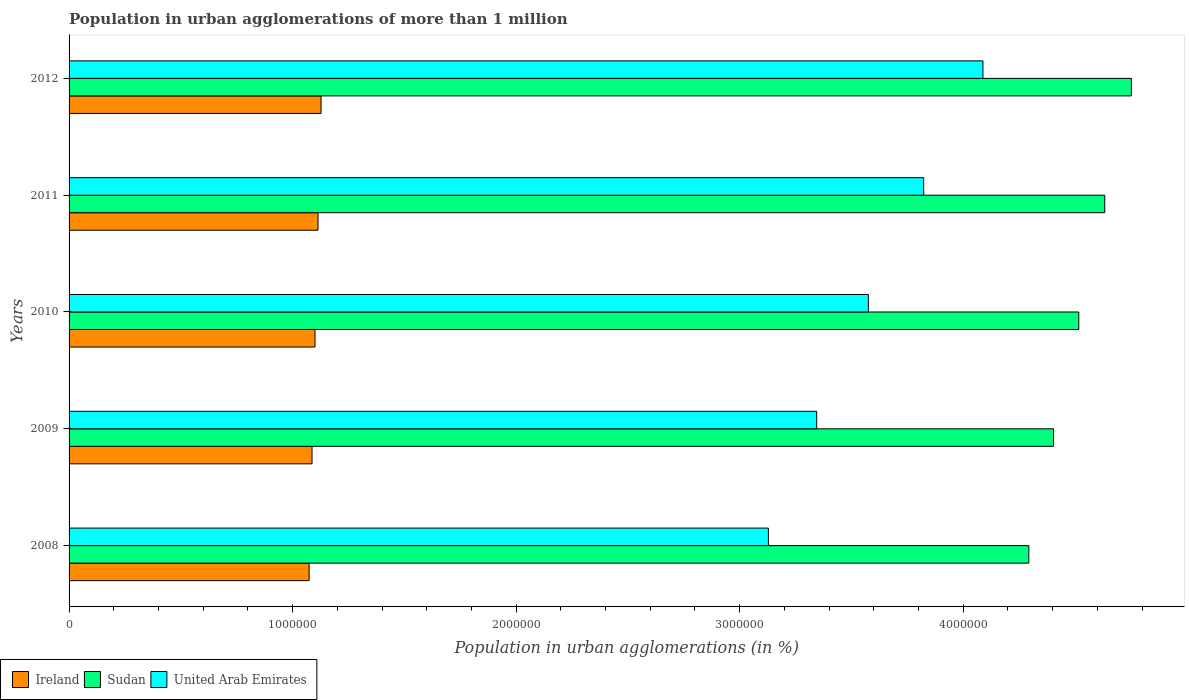How many different coloured bars are there?
Your response must be concise. 3. How many groups of bars are there?
Ensure brevity in your answer.  5. Are the number of bars per tick equal to the number of legend labels?
Give a very brief answer. Yes. Are the number of bars on each tick of the Y-axis equal?
Make the answer very short. Yes. How many bars are there on the 4th tick from the bottom?
Your answer should be very brief. 3. What is the label of the 3rd group of bars from the top?
Your answer should be very brief. 2010. In how many cases, is the number of bars for a given year not equal to the number of legend labels?
Ensure brevity in your answer.  0. What is the population in urban agglomerations in Ireland in 2012?
Your answer should be compact. 1.13e+06. Across all years, what is the maximum population in urban agglomerations in United Arab Emirates?
Offer a very short reply. 4.09e+06. Across all years, what is the minimum population in urban agglomerations in Sudan?
Give a very brief answer. 4.29e+06. In which year was the population in urban agglomerations in Ireland maximum?
Your answer should be very brief. 2012. What is the total population in urban agglomerations in United Arab Emirates in the graph?
Offer a very short reply. 1.80e+07. What is the difference between the population in urban agglomerations in Ireland in 2011 and that in 2012?
Provide a succinct answer. -1.36e+04. What is the difference between the population in urban agglomerations in Ireland in 2010 and the population in urban agglomerations in United Arab Emirates in 2008?
Keep it short and to the point. -2.03e+06. What is the average population in urban agglomerations in Ireland per year?
Give a very brief answer. 1.10e+06. In the year 2009, what is the difference between the population in urban agglomerations in Ireland and population in urban agglomerations in Sudan?
Provide a succinct answer. -3.32e+06. In how many years, is the population in urban agglomerations in Ireland greater than 600000 %?
Offer a very short reply. 5. What is the ratio of the population in urban agglomerations in United Arab Emirates in 2008 to that in 2009?
Offer a very short reply. 0.94. Is the difference between the population in urban agglomerations in Ireland in 2009 and 2010 greater than the difference between the population in urban agglomerations in Sudan in 2009 and 2010?
Keep it short and to the point. Yes. What is the difference between the highest and the second highest population in urban agglomerations in United Arab Emirates?
Your answer should be very brief. 2.65e+05. What is the difference between the highest and the lowest population in urban agglomerations in United Arab Emirates?
Offer a very short reply. 9.60e+05. In how many years, is the population in urban agglomerations in Sudan greater than the average population in urban agglomerations in Sudan taken over all years?
Keep it short and to the point. 2. What does the 3rd bar from the top in 2009 represents?
Your response must be concise. Ireland. What does the 3rd bar from the bottom in 2009 represents?
Give a very brief answer. United Arab Emirates. Is it the case that in every year, the sum of the population in urban agglomerations in Ireland and population in urban agglomerations in United Arab Emirates is greater than the population in urban agglomerations in Sudan?
Your answer should be very brief. No. Are all the bars in the graph horizontal?
Your answer should be compact. Yes. How many years are there in the graph?
Offer a very short reply. 5. Does the graph contain grids?
Your answer should be compact. No. Where does the legend appear in the graph?
Give a very brief answer. Bottom left. How many legend labels are there?
Your answer should be compact. 3. What is the title of the graph?
Give a very brief answer. Population in urban agglomerations of more than 1 million. Does "Kosovo" appear as one of the legend labels in the graph?
Your answer should be very brief. No. What is the label or title of the X-axis?
Your response must be concise. Population in urban agglomerations (in %). What is the Population in urban agglomerations (in %) of Ireland in 2008?
Offer a terse response. 1.07e+06. What is the Population in urban agglomerations (in %) in Sudan in 2008?
Your response must be concise. 4.29e+06. What is the Population in urban agglomerations (in %) in United Arab Emirates in 2008?
Your answer should be very brief. 3.13e+06. What is the Population in urban agglomerations (in %) in Ireland in 2009?
Your answer should be very brief. 1.09e+06. What is the Population in urban agglomerations (in %) of Sudan in 2009?
Make the answer very short. 4.40e+06. What is the Population in urban agglomerations (in %) in United Arab Emirates in 2009?
Your answer should be compact. 3.34e+06. What is the Population in urban agglomerations (in %) of Ireland in 2010?
Ensure brevity in your answer.  1.10e+06. What is the Population in urban agglomerations (in %) of Sudan in 2010?
Give a very brief answer. 4.52e+06. What is the Population in urban agglomerations (in %) of United Arab Emirates in 2010?
Your answer should be compact. 3.58e+06. What is the Population in urban agglomerations (in %) of Ireland in 2011?
Give a very brief answer. 1.11e+06. What is the Population in urban agglomerations (in %) of Sudan in 2011?
Ensure brevity in your answer.  4.63e+06. What is the Population in urban agglomerations (in %) in United Arab Emirates in 2011?
Provide a succinct answer. 3.82e+06. What is the Population in urban agglomerations (in %) of Ireland in 2012?
Ensure brevity in your answer.  1.13e+06. What is the Population in urban agglomerations (in %) in Sudan in 2012?
Your answer should be compact. 4.75e+06. What is the Population in urban agglomerations (in %) in United Arab Emirates in 2012?
Give a very brief answer. 4.09e+06. Across all years, what is the maximum Population in urban agglomerations (in %) in Ireland?
Provide a short and direct response. 1.13e+06. Across all years, what is the maximum Population in urban agglomerations (in %) in Sudan?
Provide a succinct answer. 4.75e+06. Across all years, what is the maximum Population in urban agglomerations (in %) in United Arab Emirates?
Give a very brief answer. 4.09e+06. Across all years, what is the minimum Population in urban agglomerations (in %) in Ireland?
Your response must be concise. 1.07e+06. Across all years, what is the minimum Population in urban agglomerations (in %) in Sudan?
Make the answer very short. 4.29e+06. Across all years, what is the minimum Population in urban agglomerations (in %) of United Arab Emirates?
Provide a short and direct response. 3.13e+06. What is the total Population in urban agglomerations (in %) in Ireland in the graph?
Offer a terse response. 5.50e+06. What is the total Population in urban agglomerations (in %) of Sudan in the graph?
Your response must be concise. 2.26e+07. What is the total Population in urban agglomerations (in %) in United Arab Emirates in the graph?
Offer a very short reply. 1.80e+07. What is the difference between the Population in urban agglomerations (in %) in Ireland in 2008 and that in 2009?
Make the answer very short. -1.31e+04. What is the difference between the Population in urban agglomerations (in %) of Sudan in 2008 and that in 2009?
Provide a short and direct response. -1.10e+05. What is the difference between the Population in urban agglomerations (in %) in United Arab Emirates in 2008 and that in 2009?
Offer a terse response. -2.16e+05. What is the difference between the Population in urban agglomerations (in %) of Ireland in 2008 and that in 2010?
Make the answer very short. -2.63e+04. What is the difference between the Population in urban agglomerations (in %) of Sudan in 2008 and that in 2010?
Provide a short and direct response. -2.24e+05. What is the difference between the Population in urban agglomerations (in %) of United Arab Emirates in 2008 and that in 2010?
Give a very brief answer. -4.47e+05. What is the difference between the Population in urban agglomerations (in %) in Ireland in 2008 and that in 2011?
Your answer should be very brief. -3.97e+04. What is the difference between the Population in urban agglomerations (in %) of Sudan in 2008 and that in 2011?
Make the answer very short. -3.40e+05. What is the difference between the Population in urban agglomerations (in %) of United Arab Emirates in 2008 and that in 2011?
Keep it short and to the point. -6.95e+05. What is the difference between the Population in urban agglomerations (in %) of Ireland in 2008 and that in 2012?
Your answer should be very brief. -5.33e+04. What is the difference between the Population in urban agglomerations (in %) of Sudan in 2008 and that in 2012?
Offer a terse response. -4.59e+05. What is the difference between the Population in urban agglomerations (in %) of United Arab Emirates in 2008 and that in 2012?
Keep it short and to the point. -9.60e+05. What is the difference between the Population in urban agglomerations (in %) in Ireland in 2009 and that in 2010?
Offer a very short reply. -1.33e+04. What is the difference between the Population in urban agglomerations (in %) in Sudan in 2009 and that in 2010?
Keep it short and to the point. -1.13e+05. What is the difference between the Population in urban agglomerations (in %) in United Arab Emirates in 2009 and that in 2010?
Keep it short and to the point. -2.31e+05. What is the difference between the Population in urban agglomerations (in %) in Ireland in 2009 and that in 2011?
Offer a very short reply. -2.67e+04. What is the difference between the Population in urban agglomerations (in %) of Sudan in 2009 and that in 2011?
Give a very brief answer. -2.29e+05. What is the difference between the Population in urban agglomerations (in %) in United Arab Emirates in 2009 and that in 2011?
Your response must be concise. -4.79e+05. What is the difference between the Population in urban agglomerations (in %) in Ireland in 2009 and that in 2012?
Offer a very short reply. -4.03e+04. What is the difference between the Population in urban agglomerations (in %) of Sudan in 2009 and that in 2012?
Keep it short and to the point. -3.48e+05. What is the difference between the Population in urban agglomerations (in %) of United Arab Emirates in 2009 and that in 2012?
Offer a terse response. -7.44e+05. What is the difference between the Population in urban agglomerations (in %) of Ireland in 2010 and that in 2011?
Ensure brevity in your answer.  -1.34e+04. What is the difference between the Population in urban agglomerations (in %) in Sudan in 2010 and that in 2011?
Provide a short and direct response. -1.16e+05. What is the difference between the Population in urban agglomerations (in %) in United Arab Emirates in 2010 and that in 2011?
Give a very brief answer. -2.47e+05. What is the difference between the Population in urban agglomerations (in %) in Ireland in 2010 and that in 2012?
Keep it short and to the point. -2.70e+04. What is the difference between the Population in urban agglomerations (in %) of Sudan in 2010 and that in 2012?
Ensure brevity in your answer.  -2.35e+05. What is the difference between the Population in urban agglomerations (in %) in United Arab Emirates in 2010 and that in 2012?
Your answer should be compact. -5.12e+05. What is the difference between the Population in urban agglomerations (in %) of Ireland in 2011 and that in 2012?
Provide a succinct answer. -1.36e+04. What is the difference between the Population in urban agglomerations (in %) of Sudan in 2011 and that in 2012?
Provide a short and direct response. -1.19e+05. What is the difference between the Population in urban agglomerations (in %) of United Arab Emirates in 2011 and that in 2012?
Give a very brief answer. -2.65e+05. What is the difference between the Population in urban agglomerations (in %) of Ireland in 2008 and the Population in urban agglomerations (in %) of Sudan in 2009?
Make the answer very short. -3.33e+06. What is the difference between the Population in urban agglomerations (in %) of Ireland in 2008 and the Population in urban agglomerations (in %) of United Arab Emirates in 2009?
Make the answer very short. -2.27e+06. What is the difference between the Population in urban agglomerations (in %) in Sudan in 2008 and the Population in urban agglomerations (in %) in United Arab Emirates in 2009?
Offer a terse response. 9.49e+05. What is the difference between the Population in urban agglomerations (in %) in Ireland in 2008 and the Population in urban agglomerations (in %) in Sudan in 2010?
Offer a terse response. -3.44e+06. What is the difference between the Population in urban agglomerations (in %) in Ireland in 2008 and the Population in urban agglomerations (in %) in United Arab Emirates in 2010?
Your answer should be very brief. -2.50e+06. What is the difference between the Population in urban agglomerations (in %) in Sudan in 2008 and the Population in urban agglomerations (in %) in United Arab Emirates in 2010?
Provide a short and direct response. 7.18e+05. What is the difference between the Population in urban agglomerations (in %) in Ireland in 2008 and the Population in urban agglomerations (in %) in Sudan in 2011?
Your answer should be very brief. -3.56e+06. What is the difference between the Population in urban agglomerations (in %) in Ireland in 2008 and the Population in urban agglomerations (in %) in United Arab Emirates in 2011?
Offer a very short reply. -2.75e+06. What is the difference between the Population in urban agglomerations (in %) of Sudan in 2008 and the Population in urban agglomerations (in %) of United Arab Emirates in 2011?
Ensure brevity in your answer.  4.70e+05. What is the difference between the Population in urban agglomerations (in %) of Ireland in 2008 and the Population in urban agglomerations (in %) of Sudan in 2012?
Offer a terse response. -3.68e+06. What is the difference between the Population in urban agglomerations (in %) of Ireland in 2008 and the Population in urban agglomerations (in %) of United Arab Emirates in 2012?
Provide a short and direct response. -3.01e+06. What is the difference between the Population in urban agglomerations (in %) in Sudan in 2008 and the Population in urban agglomerations (in %) in United Arab Emirates in 2012?
Provide a succinct answer. 2.05e+05. What is the difference between the Population in urban agglomerations (in %) of Ireland in 2009 and the Population in urban agglomerations (in %) of Sudan in 2010?
Make the answer very short. -3.43e+06. What is the difference between the Population in urban agglomerations (in %) of Ireland in 2009 and the Population in urban agglomerations (in %) of United Arab Emirates in 2010?
Provide a succinct answer. -2.49e+06. What is the difference between the Population in urban agglomerations (in %) of Sudan in 2009 and the Population in urban agglomerations (in %) of United Arab Emirates in 2010?
Ensure brevity in your answer.  8.28e+05. What is the difference between the Population in urban agglomerations (in %) in Ireland in 2009 and the Population in urban agglomerations (in %) in Sudan in 2011?
Make the answer very short. -3.55e+06. What is the difference between the Population in urban agglomerations (in %) of Ireland in 2009 and the Population in urban agglomerations (in %) of United Arab Emirates in 2011?
Your answer should be compact. -2.74e+06. What is the difference between the Population in urban agglomerations (in %) of Sudan in 2009 and the Population in urban agglomerations (in %) of United Arab Emirates in 2011?
Your answer should be compact. 5.81e+05. What is the difference between the Population in urban agglomerations (in %) in Ireland in 2009 and the Population in urban agglomerations (in %) in Sudan in 2012?
Give a very brief answer. -3.67e+06. What is the difference between the Population in urban agglomerations (in %) in Ireland in 2009 and the Population in urban agglomerations (in %) in United Arab Emirates in 2012?
Keep it short and to the point. -3.00e+06. What is the difference between the Population in urban agglomerations (in %) of Sudan in 2009 and the Population in urban agglomerations (in %) of United Arab Emirates in 2012?
Ensure brevity in your answer.  3.16e+05. What is the difference between the Population in urban agglomerations (in %) of Ireland in 2010 and the Population in urban agglomerations (in %) of Sudan in 2011?
Ensure brevity in your answer.  -3.53e+06. What is the difference between the Population in urban agglomerations (in %) in Ireland in 2010 and the Population in urban agglomerations (in %) in United Arab Emirates in 2011?
Offer a very short reply. -2.72e+06. What is the difference between the Population in urban agglomerations (in %) of Sudan in 2010 and the Population in urban agglomerations (in %) of United Arab Emirates in 2011?
Offer a terse response. 6.94e+05. What is the difference between the Population in urban agglomerations (in %) in Ireland in 2010 and the Population in urban agglomerations (in %) in Sudan in 2012?
Offer a very short reply. -3.65e+06. What is the difference between the Population in urban agglomerations (in %) of Ireland in 2010 and the Population in urban agglomerations (in %) of United Arab Emirates in 2012?
Keep it short and to the point. -2.99e+06. What is the difference between the Population in urban agglomerations (in %) in Sudan in 2010 and the Population in urban agglomerations (in %) in United Arab Emirates in 2012?
Offer a terse response. 4.29e+05. What is the difference between the Population in urban agglomerations (in %) in Ireland in 2011 and the Population in urban agglomerations (in %) in Sudan in 2012?
Your answer should be very brief. -3.64e+06. What is the difference between the Population in urban agglomerations (in %) in Ireland in 2011 and the Population in urban agglomerations (in %) in United Arab Emirates in 2012?
Your answer should be very brief. -2.97e+06. What is the difference between the Population in urban agglomerations (in %) in Sudan in 2011 and the Population in urban agglomerations (in %) in United Arab Emirates in 2012?
Offer a terse response. 5.45e+05. What is the average Population in urban agglomerations (in %) of Ireland per year?
Offer a very short reply. 1.10e+06. What is the average Population in urban agglomerations (in %) in Sudan per year?
Your response must be concise. 4.52e+06. What is the average Population in urban agglomerations (in %) of United Arab Emirates per year?
Offer a very short reply. 3.59e+06. In the year 2008, what is the difference between the Population in urban agglomerations (in %) in Ireland and Population in urban agglomerations (in %) in Sudan?
Keep it short and to the point. -3.22e+06. In the year 2008, what is the difference between the Population in urban agglomerations (in %) of Ireland and Population in urban agglomerations (in %) of United Arab Emirates?
Make the answer very short. -2.05e+06. In the year 2008, what is the difference between the Population in urban agglomerations (in %) in Sudan and Population in urban agglomerations (in %) in United Arab Emirates?
Keep it short and to the point. 1.17e+06. In the year 2009, what is the difference between the Population in urban agglomerations (in %) of Ireland and Population in urban agglomerations (in %) of Sudan?
Ensure brevity in your answer.  -3.32e+06. In the year 2009, what is the difference between the Population in urban agglomerations (in %) of Ireland and Population in urban agglomerations (in %) of United Arab Emirates?
Your response must be concise. -2.26e+06. In the year 2009, what is the difference between the Population in urban agglomerations (in %) of Sudan and Population in urban agglomerations (in %) of United Arab Emirates?
Offer a terse response. 1.06e+06. In the year 2010, what is the difference between the Population in urban agglomerations (in %) in Ireland and Population in urban agglomerations (in %) in Sudan?
Make the answer very short. -3.42e+06. In the year 2010, what is the difference between the Population in urban agglomerations (in %) of Ireland and Population in urban agglomerations (in %) of United Arab Emirates?
Give a very brief answer. -2.48e+06. In the year 2010, what is the difference between the Population in urban agglomerations (in %) of Sudan and Population in urban agglomerations (in %) of United Arab Emirates?
Provide a succinct answer. 9.41e+05. In the year 2011, what is the difference between the Population in urban agglomerations (in %) in Ireland and Population in urban agglomerations (in %) in Sudan?
Offer a very short reply. -3.52e+06. In the year 2011, what is the difference between the Population in urban agglomerations (in %) in Ireland and Population in urban agglomerations (in %) in United Arab Emirates?
Your answer should be very brief. -2.71e+06. In the year 2011, what is the difference between the Population in urban agglomerations (in %) in Sudan and Population in urban agglomerations (in %) in United Arab Emirates?
Make the answer very short. 8.10e+05. In the year 2012, what is the difference between the Population in urban agglomerations (in %) of Ireland and Population in urban agglomerations (in %) of Sudan?
Your answer should be compact. -3.63e+06. In the year 2012, what is the difference between the Population in urban agglomerations (in %) in Ireland and Population in urban agglomerations (in %) in United Arab Emirates?
Ensure brevity in your answer.  -2.96e+06. In the year 2012, what is the difference between the Population in urban agglomerations (in %) of Sudan and Population in urban agglomerations (in %) of United Arab Emirates?
Your response must be concise. 6.64e+05. What is the ratio of the Population in urban agglomerations (in %) in Sudan in 2008 to that in 2009?
Your response must be concise. 0.97. What is the ratio of the Population in urban agglomerations (in %) in United Arab Emirates in 2008 to that in 2009?
Keep it short and to the point. 0.94. What is the ratio of the Population in urban agglomerations (in %) in Ireland in 2008 to that in 2010?
Your answer should be compact. 0.98. What is the ratio of the Population in urban agglomerations (in %) in Sudan in 2008 to that in 2010?
Your answer should be very brief. 0.95. What is the ratio of the Population in urban agglomerations (in %) of United Arab Emirates in 2008 to that in 2010?
Give a very brief answer. 0.87. What is the ratio of the Population in urban agglomerations (in %) of Ireland in 2008 to that in 2011?
Give a very brief answer. 0.96. What is the ratio of the Population in urban agglomerations (in %) in Sudan in 2008 to that in 2011?
Your answer should be compact. 0.93. What is the ratio of the Population in urban agglomerations (in %) in United Arab Emirates in 2008 to that in 2011?
Provide a succinct answer. 0.82. What is the ratio of the Population in urban agglomerations (in %) of Ireland in 2008 to that in 2012?
Provide a succinct answer. 0.95. What is the ratio of the Population in urban agglomerations (in %) of Sudan in 2008 to that in 2012?
Provide a succinct answer. 0.9. What is the ratio of the Population in urban agglomerations (in %) of United Arab Emirates in 2008 to that in 2012?
Give a very brief answer. 0.77. What is the ratio of the Population in urban agglomerations (in %) of Sudan in 2009 to that in 2010?
Keep it short and to the point. 0.97. What is the ratio of the Population in urban agglomerations (in %) in United Arab Emirates in 2009 to that in 2010?
Your answer should be very brief. 0.94. What is the ratio of the Population in urban agglomerations (in %) in Ireland in 2009 to that in 2011?
Give a very brief answer. 0.98. What is the ratio of the Population in urban agglomerations (in %) in Sudan in 2009 to that in 2011?
Your response must be concise. 0.95. What is the ratio of the Population in urban agglomerations (in %) of United Arab Emirates in 2009 to that in 2011?
Your answer should be compact. 0.87. What is the ratio of the Population in urban agglomerations (in %) in Ireland in 2009 to that in 2012?
Your answer should be compact. 0.96. What is the ratio of the Population in urban agglomerations (in %) of Sudan in 2009 to that in 2012?
Your answer should be very brief. 0.93. What is the ratio of the Population in urban agglomerations (in %) in United Arab Emirates in 2009 to that in 2012?
Your response must be concise. 0.82. What is the ratio of the Population in urban agglomerations (in %) of Sudan in 2010 to that in 2011?
Your response must be concise. 0.97. What is the ratio of the Population in urban agglomerations (in %) in United Arab Emirates in 2010 to that in 2011?
Ensure brevity in your answer.  0.94. What is the ratio of the Population in urban agglomerations (in %) of Ireland in 2010 to that in 2012?
Your answer should be compact. 0.98. What is the ratio of the Population in urban agglomerations (in %) in Sudan in 2010 to that in 2012?
Offer a terse response. 0.95. What is the ratio of the Population in urban agglomerations (in %) of United Arab Emirates in 2010 to that in 2012?
Your answer should be compact. 0.87. What is the ratio of the Population in urban agglomerations (in %) of Sudan in 2011 to that in 2012?
Offer a terse response. 0.97. What is the ratio of the Population in urban agglomerations (in %) in United Arab Emirates in 2011 to that in 2012?
Offer a terse response. 0.94. What is the difference between the highest and the second highest Population in urban agglomerations (in %) of Ireland?
Make the answer very short. 1.36e+04. What is the difference between the highest and the second highest Population in urban agglomerations (in %) in Sudan?
Provide a short and direct response. 1.19e+05. What is the difference between the highest and the second highest Population in urban agglomerations (in %) of United Arab Emirates?
Make the answer very short. 2.65e+05. What is the difference between the highest and the lowest Population in urban agglomerations (in %) of Ireland?
Keep it short and to the point. 5.33e+04. What is the difference between the highest and the lowest Population in urban agglomerations (in %) in Sudan?
Your answer should be very brief. 4.59e+05. What is the difference between the highest and the lowest Population in urban agglomerations (in %) in United Arab Emirates?
Provide a succinct answer. 9.60e+05. 